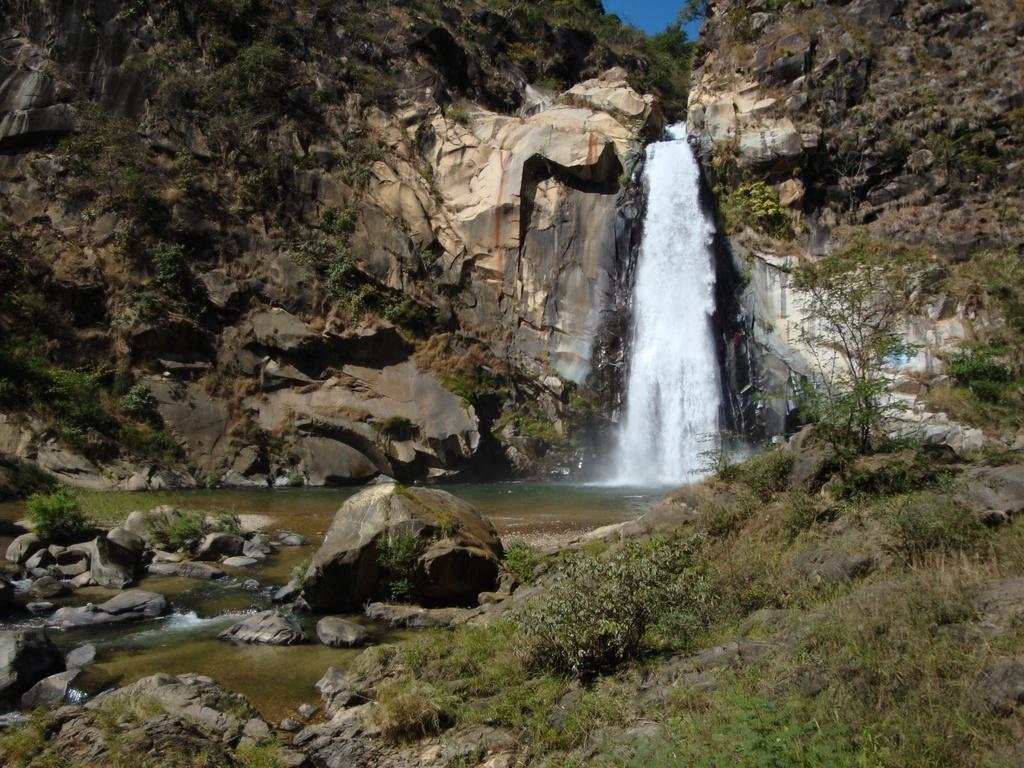Please provide a concise description of this image. In the center of the image we can see a waterfall. At the bottom there are rocks and grass. In the background there are hills and sky. 